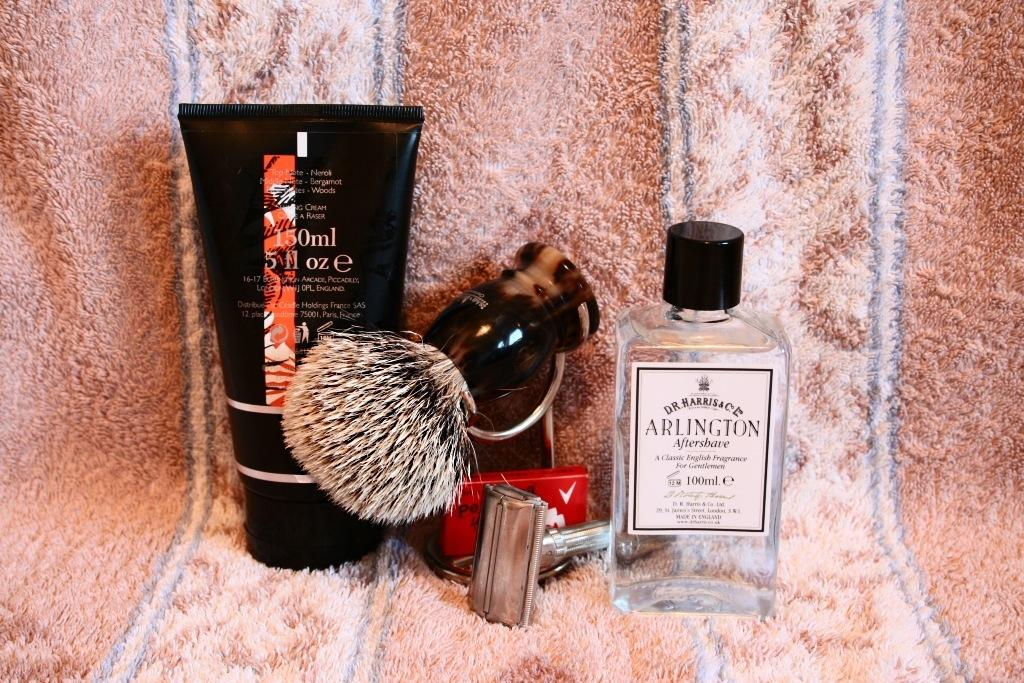<image>
Offer a succinct explanation of the picture presented. A shaving kit including Arlington Aftershave lays on a pink striped towel. 